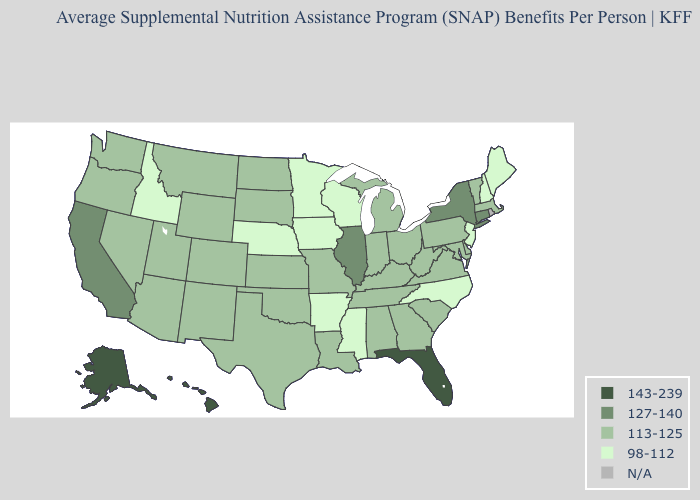Among the states that border West Virginia , which have the lowest value?
Concise answer only. Kentucky, Maryland, Ohio, Pennsylvania, Virginia. Does Wisconsin have the highest value in the USA?
Quick response, please. No. What is the value of South Dakota?
Give a very brief answer. 113-125. What is the highest value in the West ?
Give a very brief answer. 143-239. Which states have the lowest value in the USA?
Be succinct. Arkansas, Idaho, Iowa, Maine, Minnesota, Mississippi, Nebraska, New Hampshire, New Jersey, North Carolina, Wisconsin. What is the value of Vermont?
Answer briefly. 113-125. What is the lowest value in the West?
Give a very brief answer. 98-112. How many symbols are there in the legend?
Short answer required. 5. Name the states that have a value in the range 113-125?
Quick response, please. Alabama, Arizona, Colorado, Delaware, Georgia, Indiana, Kansas, Kentucky, Louisiana, Maryland, Massachusetts, Michigan, Missouri, Montana, Nevada, New Mexico, North Dakota, Ohio, Oklahoma, Oregon, Pennsylvania, South Carolina, South Dakota, Tennessee, Texas, Utah, Vermont, Virginia, Washington, West Virginia, Wyoming. What is the highest value in states that border Montana?
Answer briefly. 113-125. Among the states that border Vermont , does Massachusetts have the highest value?
Concise answer only. No. How many symbols are there in the legend?
Keep it brief. 5. What is the highest value in states that border Arizona?
Concise answer only. 127-140. Among the states that border New Jersey , which have the lowest value?
Write a very short answer. Delaware, Pennsylvania. 